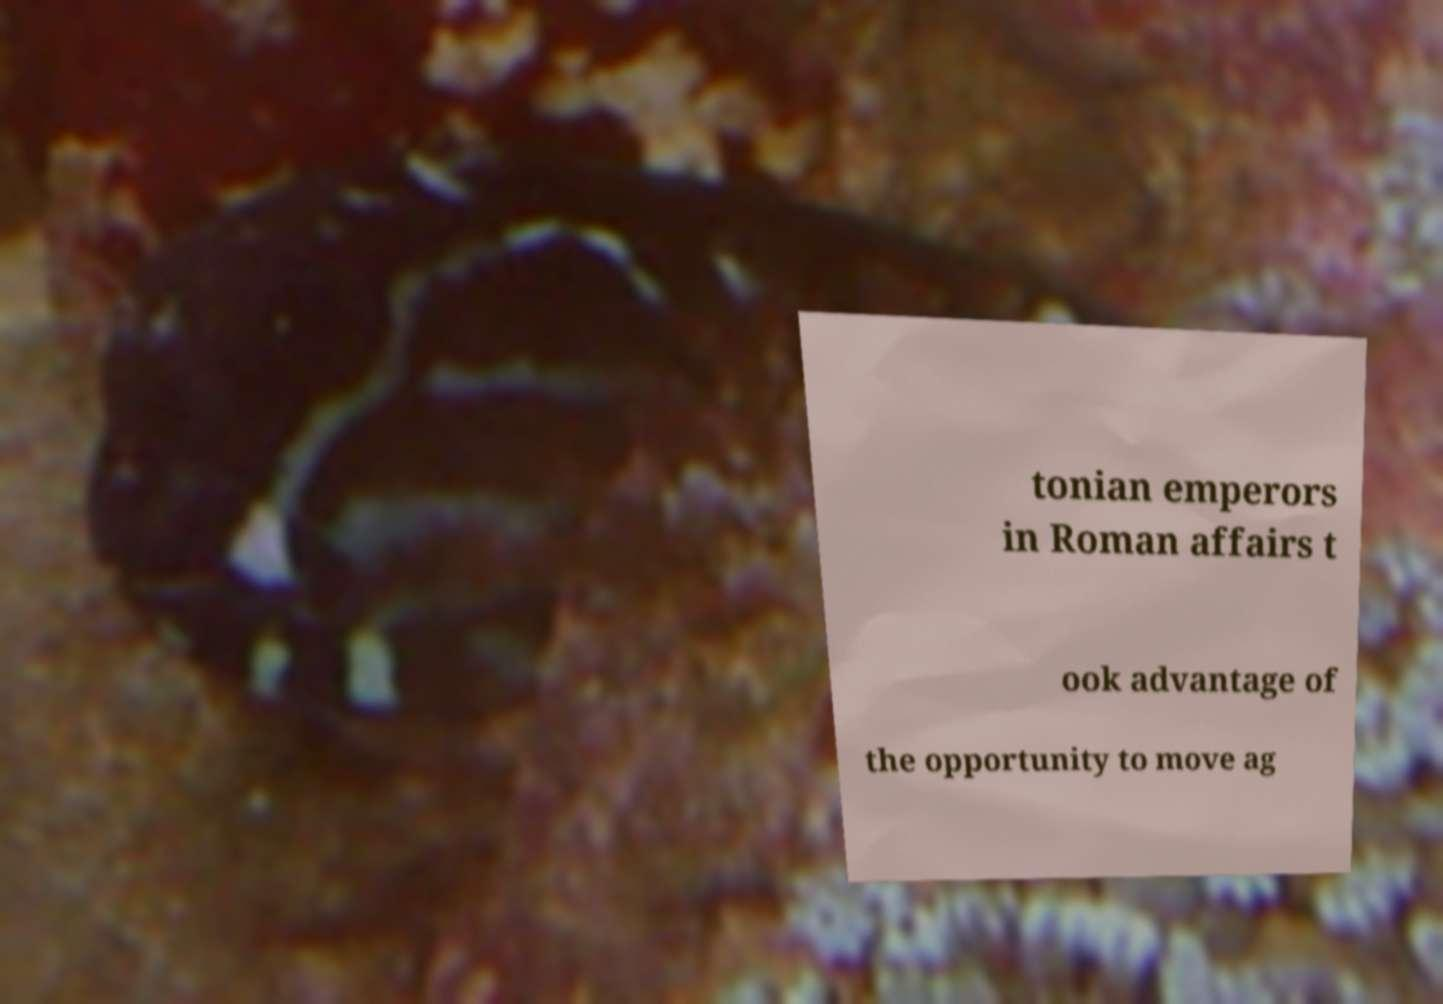Can you accurately transcribe the text from the provided image for me? tonian emperors in Roman affairs t ook advantage of the opportunity to move ag 